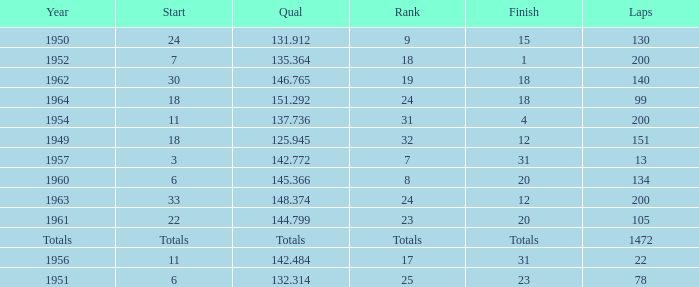Name the rank with finish of 12 and year of 1963 24.0. 